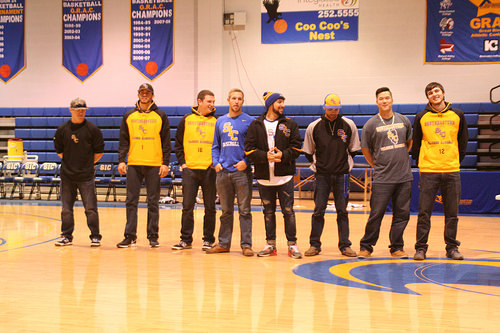<image>
Can you confirm if the man is on the floor? Yes. Looking at the image, I can see the man is positioned on top of the floor, with the floor providing support. Is the hat on the man? No. The hat is not positioned on the man. They may be near each other, but the hat is not supported by or resting on top of the man. Is there a boy next to the boy? No. The boy is not positioned next to the boy. They are located in different areas of the scene. 